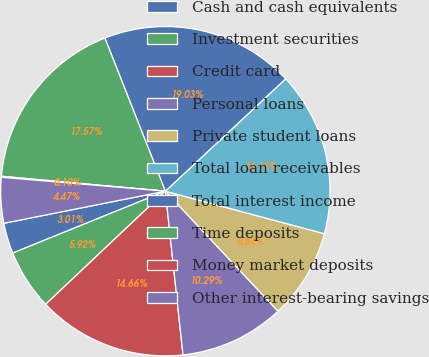Convert chart. <chart><loc_0><loc_0><loc_500><loc_500><pie_chart><fcel>Cash and cash equivalents<fcel>Investment securities<fcel>Credit card<fcel>Personal loans<fcel>Private student loans<fcel>Total loan receivables<fcel>Total interest income<fcel>Time deposits<fcel>Money market deposits<fcel>Other interest-bearing savings<nl><fcel>3.01%<fcel>5.92%<fcel>14.66%<fcel>10.29%<fcel>8.84%<fcel>16.12%<fcel>19.03%<fcel>17.57%<fcel>0.1%<fcel>4.47%<nl></chart> 